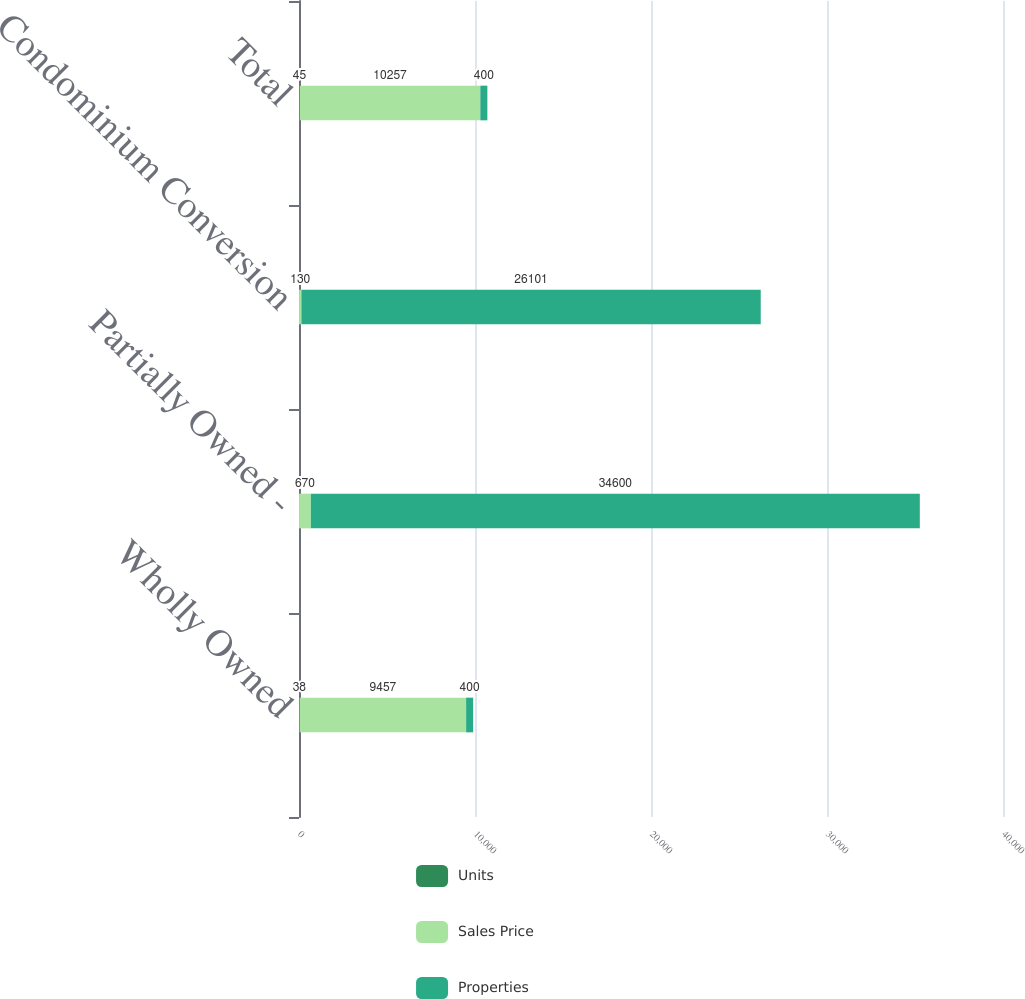<chart> <loc_0><loc_0><loc_500><loc_500><stacked_bar_chart><ecel><fcel>Wholly Owned<fcel>Partially Owned -<fcel>Condominium Conversion<fcel>Total<nl><fcel>Units<fcel>38<fcel>3<fcel>4<fcel>45<nl><fcel>Sales Price<fcel>9457<fcel>670<fcel>130<fcel>10257<nl><fcel>Properties<fcel>400<fcel>34600<fcel>26101<fcel>400<nl></chart> 